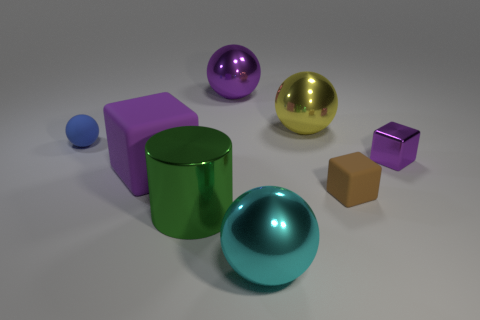Add 2 big objects. How many objects exist? 10 Subtract all cylinders. How many objects are left? 7 Add 4 tiny things. How many tiny things exist? 7 Subtract 0 purple cylinders. How many objects are left? 8 Subtract all large yellow balls. Subtract all small matte cubes. How many objects are left? 6 Add 1 large matte blocks. How many large matte blocks are left? 2 